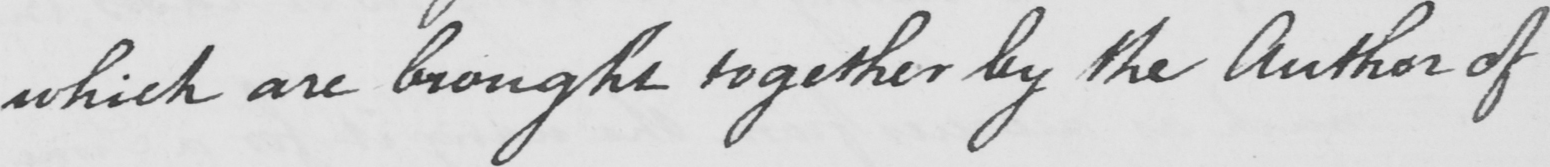Can you tell me what this handwritten text says? which are brought together by the Author of 